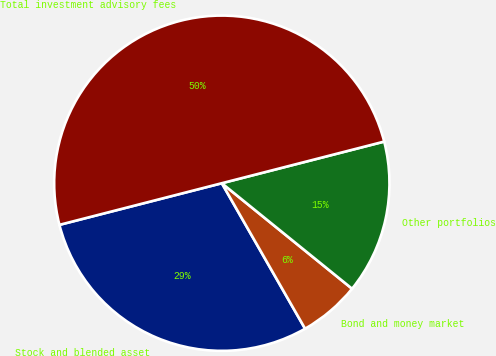<chart> <loc_0><loc_0><loc_500><loc_500><pie_chart><fcel>Stock and blended asset<fcel>Bond and money market<fcel>Other portfolios<fcel>Total investment advisory fees<nl><fcel>29.28%<fcel>5.89%<fcel>14.83%<fcel>50.0%<nl></chart> 